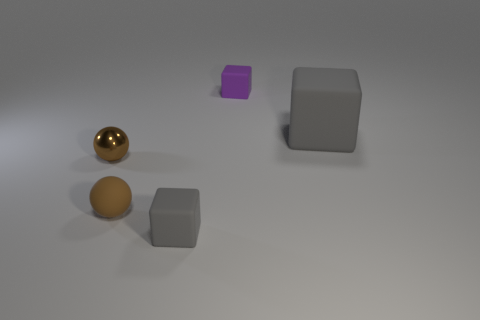Are there any tiny gray blocks made of the same material as the tiny gray object?
Offer a very short reply. No. There is a purple thing; is it the same size as the gray matte cube that is left of the large gray rubber cube?
Give a very brief answer. Yes. Are there any other small objects that have the same color as the shiny object?
Give a very brief answer. Yes. Do the purple thing and the large gray block have the same material?
Offer a very short reply. Yes. There is a rubber ball; what number of tiny balls are in front of it?
Provide a succinct answer. 0. There is a small thing that is both in front of the shiny thing and to the right of the small rubber sphere; what material is it?
Provide a short and direct response. Rubber. What number of purple balls are the same size as the purple rubber cube?
Offer a very short reply. 0. There is a ball in front of the brown thing behind the brown matte object; what color is it?
Give a very brief answer. Brown. Is there a tiny blue rubber cube?
Provide a succinct answer. No. Is the large rubber thing the same shape as the brown metallic thing?
Your answer should be compact. No. 